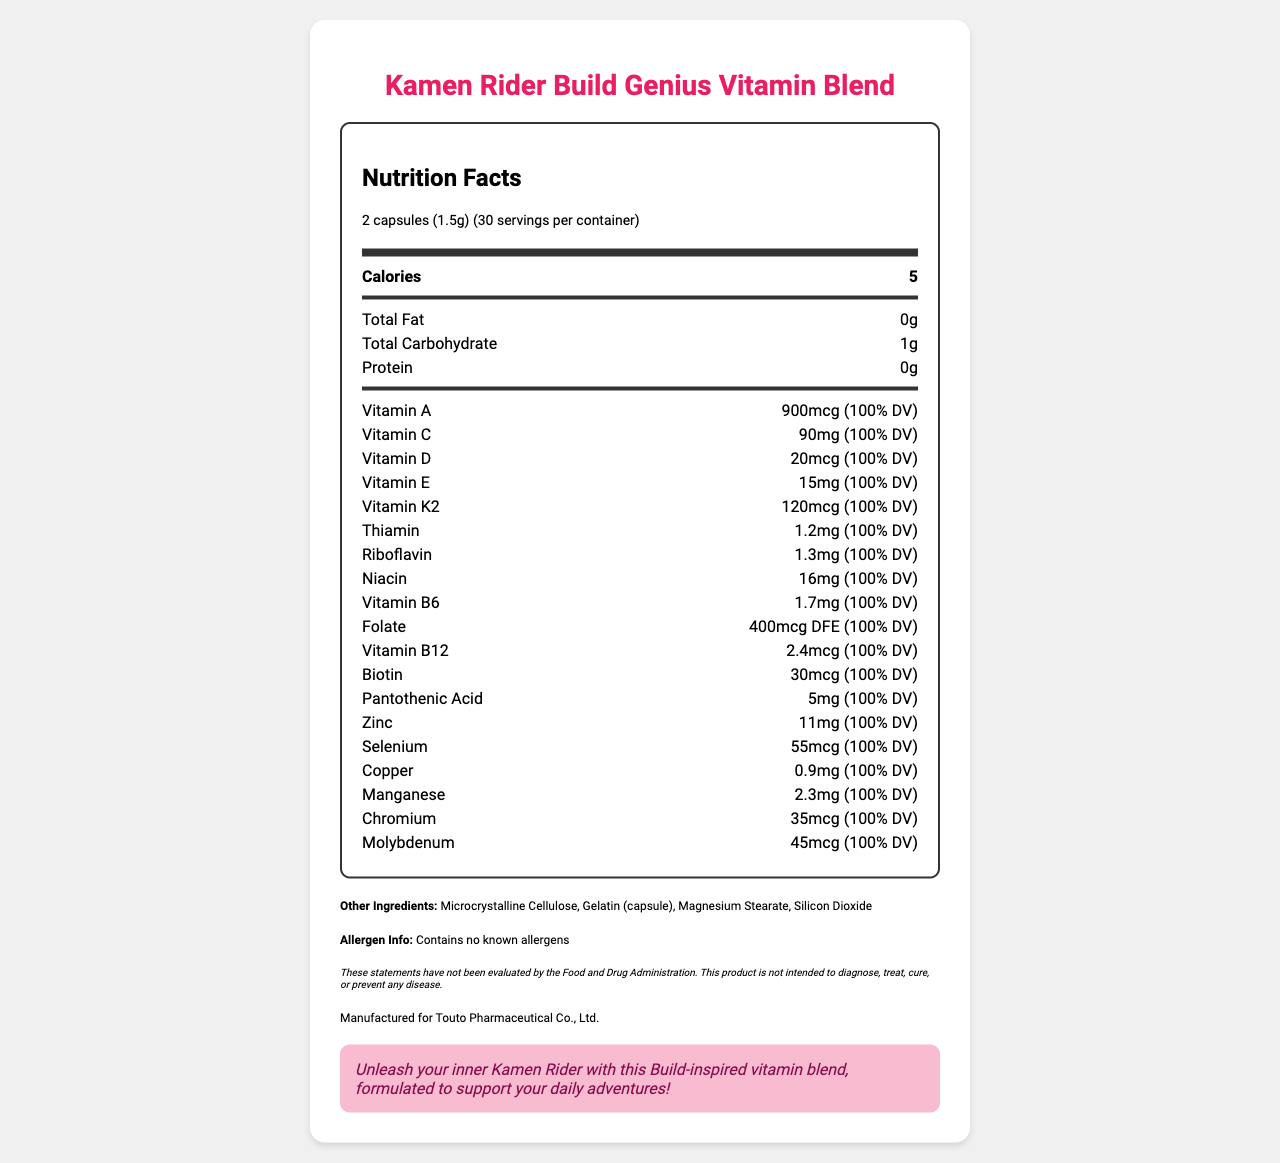What is the serving size of Kamen Rider Build Genius Vitamin Blend? The serving size is clearly indicated at the top of the nutrition label as "2 capsules (1.5g)".
Answer: 2 capsules (1.5g) How many servings per container are there? The servings per container are mentioned directly below the serving size as "30".
Answer: 30 How many calories are there per serving? The number of calories per serving is listed in the main nutrient section as "5".
Answer: 5 What percentage of the Daily Value (DV) of Vitamin A is provided per serving? The label indicates that each serving provides "900mcg (100% DV)" for Vitamin A.
Answer: 100% DV List two other ingredients found in the supplement apart from the active vitamins and minerals. The other ingredients section lists "Microcrystalline Cellulose" and "Gelatin (capsule)" among others.
Answer: Microcrystalline Cellulose, Gelatin (capsule) Does this product contain any known allergens? The allergen information states, "Contains no known allergens".
Answer: No What is the total amount of carbohydrates per serving? The total carbohydrate content is listed under the main nutrient section as "1g".
Answer: 1g Which company manufactures the Kamen Rider Build Genius Vitamin Blend? The manufacturer information is listed as "Manufactured for Touto Pharmaceutical Co., Ltd."
Answer: Touto Pharmaceutical Co., Ltd. What is the flavor text found on the document? The flavor text is given as a motivational tagline at the bottom of the document.
Answer: "Unleash your inner Kamen Rider with this Build-inspired vitamin blend, formulated to support your daily adventures!" Of the following vitamins, which one is included in the supplement? A. Vitamin B7 B. Vitamin B12 C. Vitamin B9 D. Vitamin B5 The document lists "Vitamin B12" as one of the vitamins included, while A, C, and D are not mentioned with those specific numbers (Vitamin B9 is folate).
Answer: B Which statement is true about the product? I. It contains 15mg of Vitamin C. II. It contains 20mcg of Vitamin D. III. It has 5mg of Pantothenic Acid. The document indicates 20mcg of Vitamin D and 5mg of Pantothenic Acid per serving. The amount of Vitamin C per serving is 90mg, not 15mg.
Answer: II and III Is the statement "This product is intended to diagnose, treat, cure, or prevent any disease." true or false? The disclaimer explicitly states that the product is not intended for diagnosing, treating, curing, or preventing any disease.
Answer: False Summarize the main idea of the document. The main idea of the document is to offer consumers detailed information about the nutritional content and supplementary ingredients of the Kamen Rider Build Genius Vitamin Blend, alongside a motivational tagline related to the Kamen Rider Build series.
Answer: The document provides detailed nutritional information for the Kamen Rider Build Genius Vitamin Blend supplement, including serving size, servings per container, calories, and a comprehensive list of vitamins, minerals, and other ingredients. It also includes allergen information, a disclaimer about the product's health claims, and a flavor text aimed at Kamen Rider fans. What is the source of microcrystalline cellulose in this supplement? The document lists microcrystalline cellulose as an ingredient but does not provide information about its source.
Answer: Not enough information 